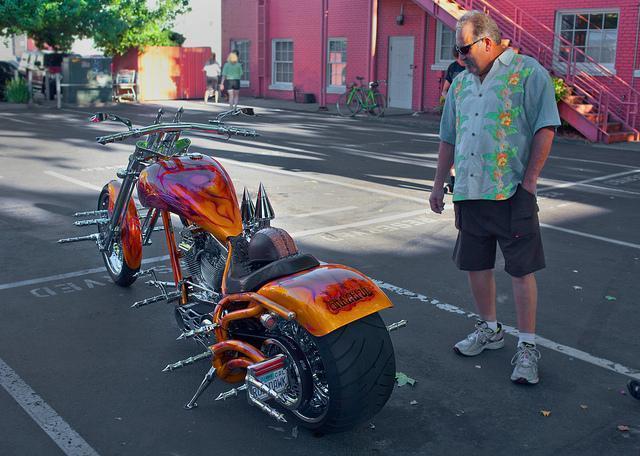How was this type of bike made?
From the following four choices, select the correct answer to address the question.
Options: Trade, custom, retail, assembly line. Custom. 